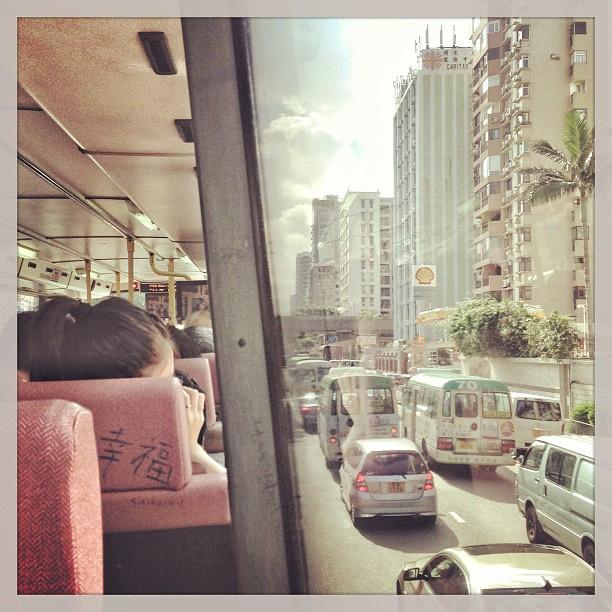What gas station can you see?
Short answer required. Shell. What color are the seats?
Write a very short answer. Red. What sort of buildings line the street?
Concise answer only. Apartment. 